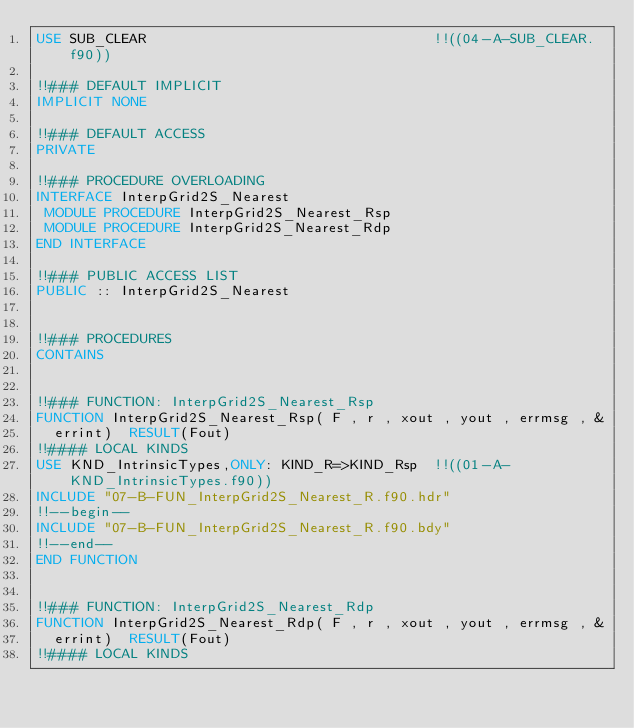<code> <loc_0><loc_0><loc_500><loc_500><_FORTRAN_>USE SUB_CLEAR                                  !!((04-A-SUB_CLEAR.f90))

!!### DEFAULT IMPLICIT
IMPLICIT NONE

!!### DEFAULT ACCESS
PRIVATE

!!### PROCEDURE OVERLOADING
INTERFACE InterpGrid2S_Nearest
 MODULE PROCEDURE InterpGrid2S_Nearest_Rsp
 MODULE PROCEDURE InterpGrid2S_Nearest_Rdp
END INTERFACE

!!### PUBLIC ACCESS LIST
PUBLIC :: InterpGrid2S_Nearest


!!### PROCEDURES
CONTAINS


!!### FUNCTION: InterpGrid2S_Nearest_Rsp
FUNCTION InterpGrid2S_Nearest_Rsp( F , r , xout , yout , errmsg , &
  errint)  RESULT(Fout)
!!#### LOCAL KINDS
USE KND_IntrinsicTypes,ONLY: KIND_R=>KIND_Rsp  !!((01-A-KND_IntrinsicTypes.f90))
INCLUDE "07-B-FUN_InterpGrid2S_Nearest_R.f90.hdr"
!!--begin--
INCLUDE "07-B-FUN_InterpGrid2S_Nearest_R.f90.bdy"
!!--end--
END FUNCTION


!!### FUNCTION: InterpGrid2S_Nearest_Rdp
FUNCTION InterpGrid2S_Nearest_Rdp( F , r , xout , yout , errmsg , &
  errint)  RESULT(Fout)
!!#### LOCAL KINDS</code> 